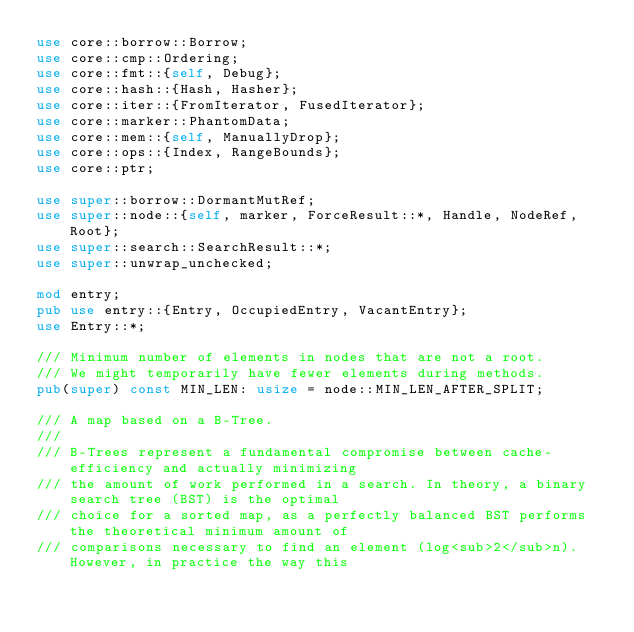<code> <loc_0><loc_0><loc_500><loc_500><_Rust_>use core::borrow::Borrow;
use core::cmp::Ordering;
use core::fmt::{self, Debug};
use core::hash::{Hash, Hasher};
use core::iter::{FromIterator, FusedIterator};
use core::marker::PhantomData;
use core::mem::{self, ManuallyDrop};
use core::ops::{Index, RangeBounds};
use core::ptr;

use super::borrow::DormantMutRef;
use super::node::{self, marker, ForceResult::*, Handle, NodeRef, Root};
use super::search::SearchResult::*;
use super::unwrap_unchecked;

mod entry;
pub use entry::{Entry, OccupiedEntry, VacantEntry};
use Entry::*;

/// Minimum number of elements in nodes that are not a root.
/// We might temporarily have fewer elements during methods.
pub(super) const MIN_LEN: usize = node::MIN_LEN_AFTER_SPLIT;

/// A map based on a B-Tree.
///
/// B-Trees represent a fundamental compromise between cache-efficiency and actually minimizing
/// the amount of work performed in a search. In theory, a binary search tree (BST) is the optimal
/// choice for a sorted map, as a perfectly balanced BST performs the theoretical minimum amount of
/// comparisons necessary to find an element (log<sub>2</sub>n). However, in practice the way this</code> 